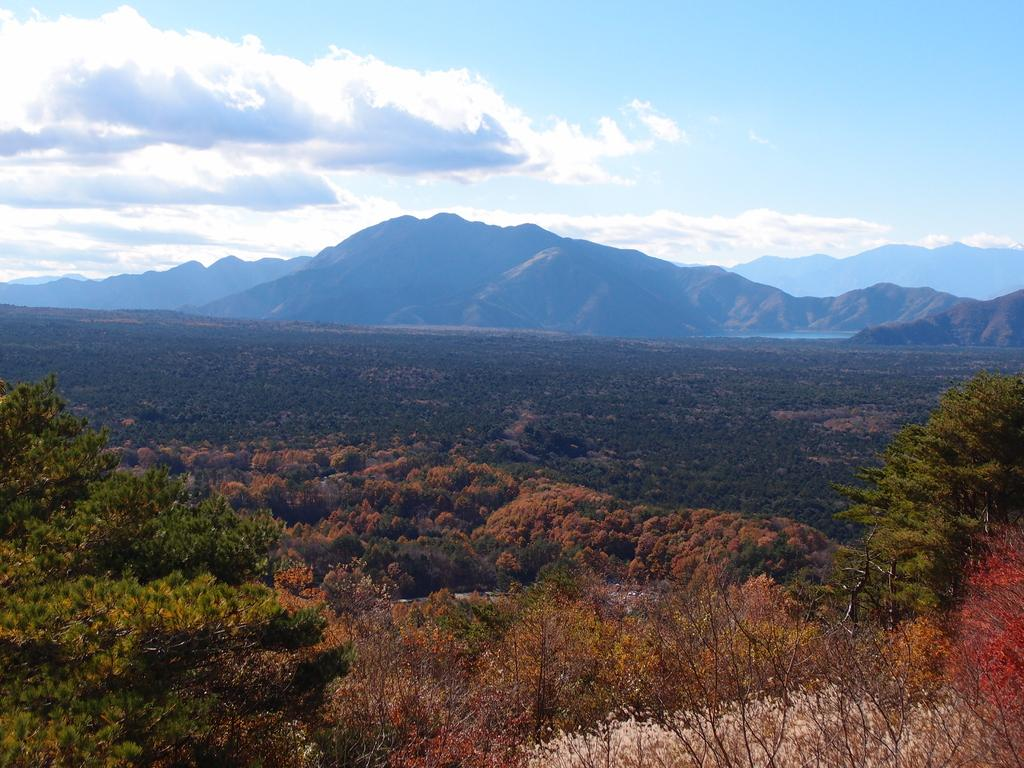What type of vegetation is present in the image? There are trees in the image. What geographical features can be seen in the middle of the image? There are hills in the middle of the image. What is visible at the top of the image? The sky is visible at the top of the image. What type of metal is used to create the partner's test in the image? There is no partner or test present in the image, and therefore no metal can be associated with them. 